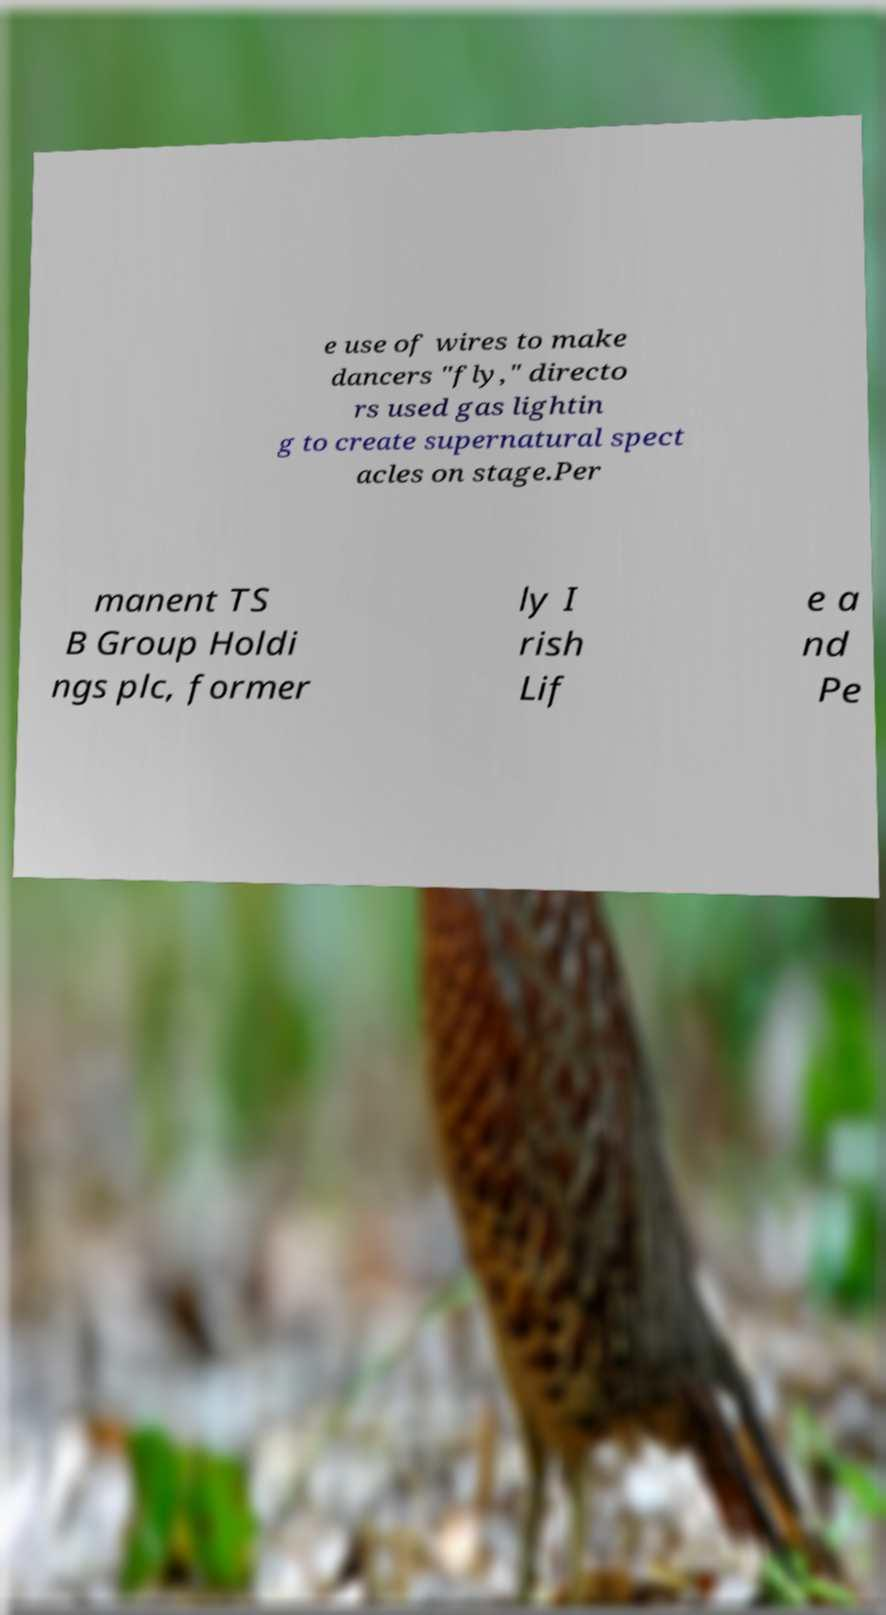Please identify and transcribe the text found in this image. e use of wires to make dancers "fly," directo rs used gas lightin g to create supernatural spect acles on stage.Per manent TS B Group Holdi ngs plc, former ly I rish Lif e a nd Pe 